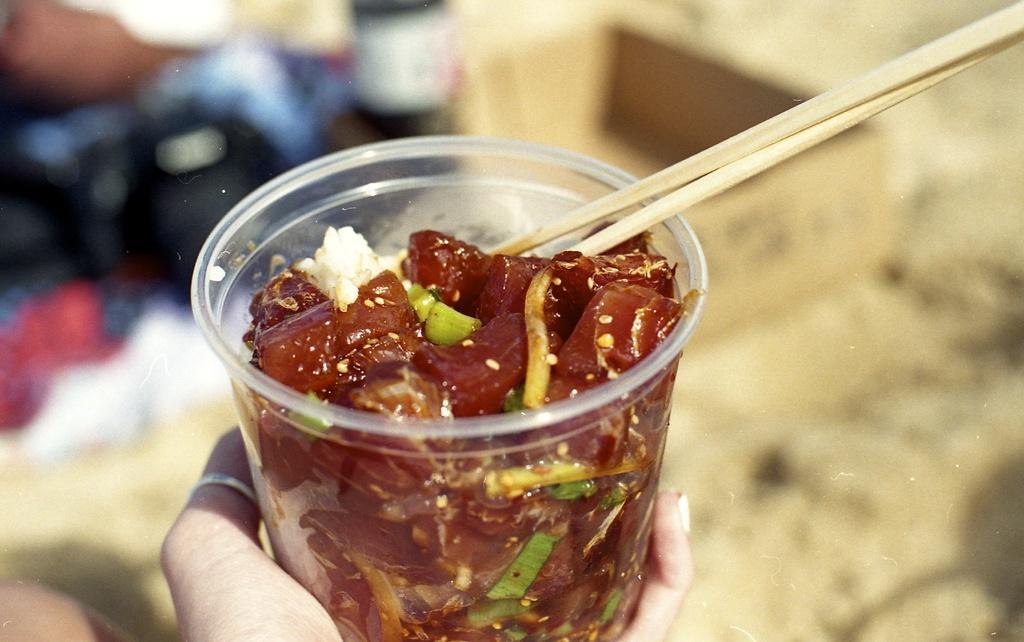Describe this image in one or two sentences. In this image i can see a human hand holding a cup there is food in side the cup and two sticks. 